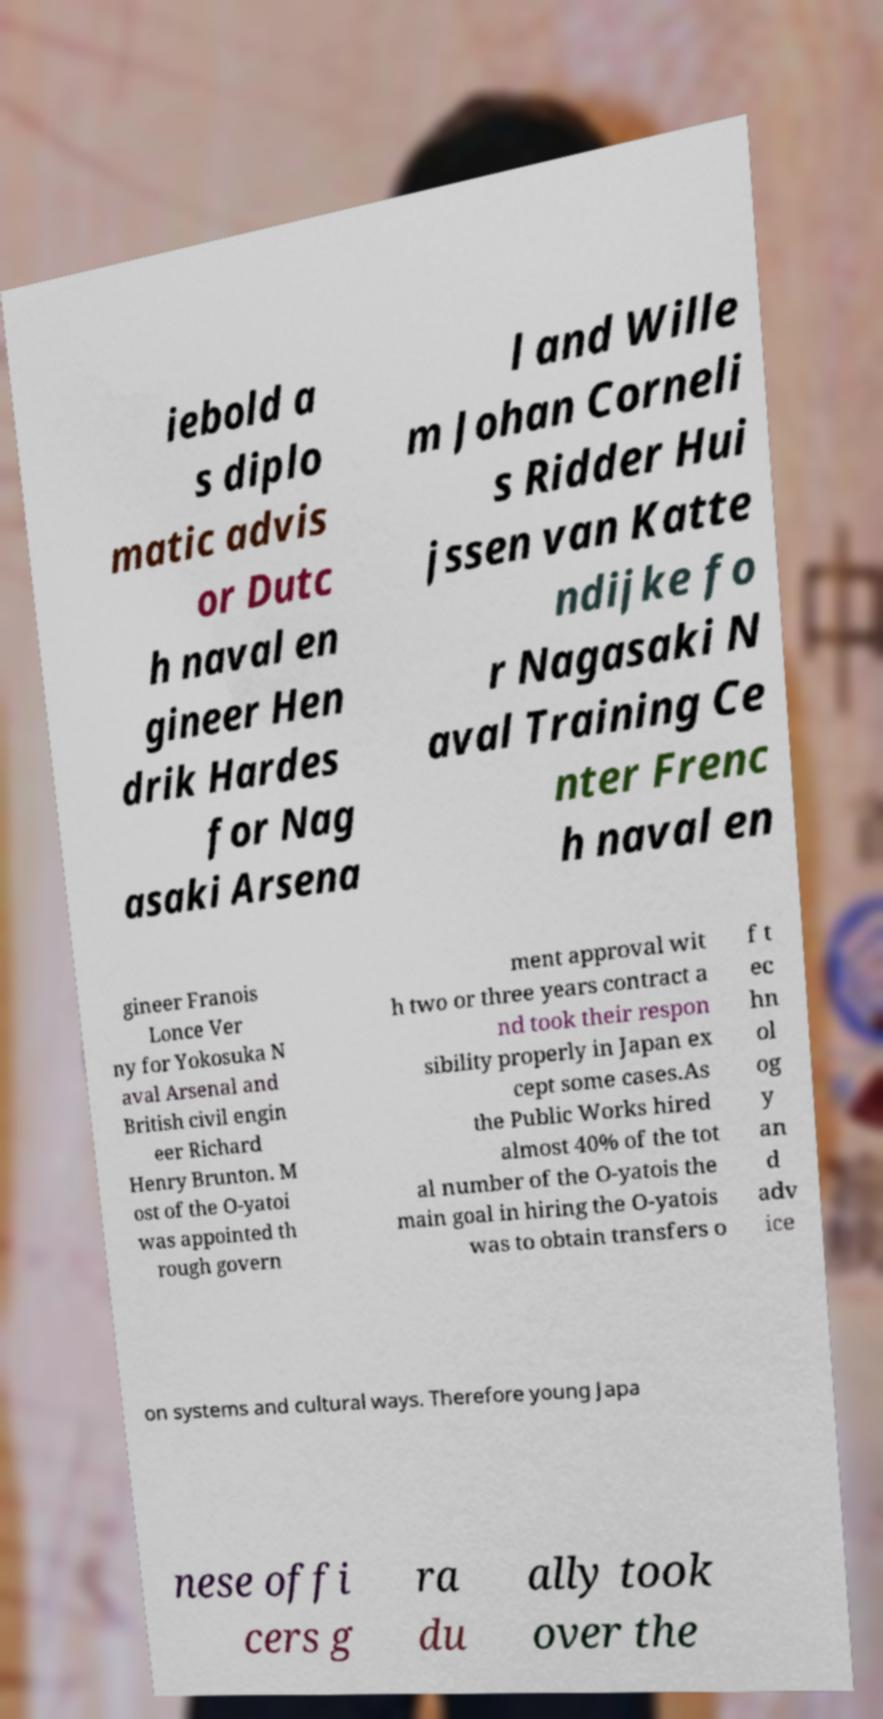Please identify and transcribe the text found in this image. iebold a s diplo matic advis or Dutc h naval en gineer Hen drik Hardes for Nag asaki Arsena l and Wille m Johan Corneli s Ridder Hui jssen van Katte ndijke fo r Nagasaki N aval Training Ce nter Frenc h naval en gineer Franois Lonce Ver ny for Yokosuka N aval Arsenal and British civil engin eer Richard Henry Brunton. M ost of the O-yatoi was appointed th rough govern ment approval wit h two or three years contract a nd took their respon sibility properly in Japan ex cept some cases.As the Public Works hired almost 40% of the tot al number of the O-yatois the main goal in hiring the O-yatois was to obtain transfers o f t ec hn ol og y an d adv ice on systems and cultural ways. Therefore young Japa nese offi cers g ra du ally took over the 